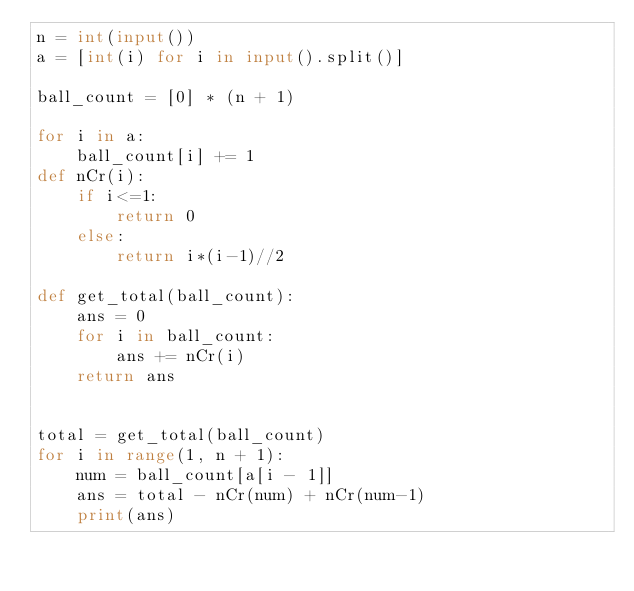<code> <loc_0><loc_0><loc_500><loc_500><_Python_>n = int(input())
a = [int(i) for i in input().split()]

ball_count = [0] * (n + 1)

for i in a:
    ball_count[i] += 1
def nCr(i):
    if i<=1:
        return 0
    else:
        return i*(i-1)//2

def get_total(ball_count):
    ans = 0
    for i in ball_count:
        ans += nCr(i)
    return ans


total = get_total(ball_count)
for i in range(1, n + 1):
    num = ball_count[a[i - 1]]
    ans = total - nCr(num) + nCr(num-1)
    print(ans)
</code> 